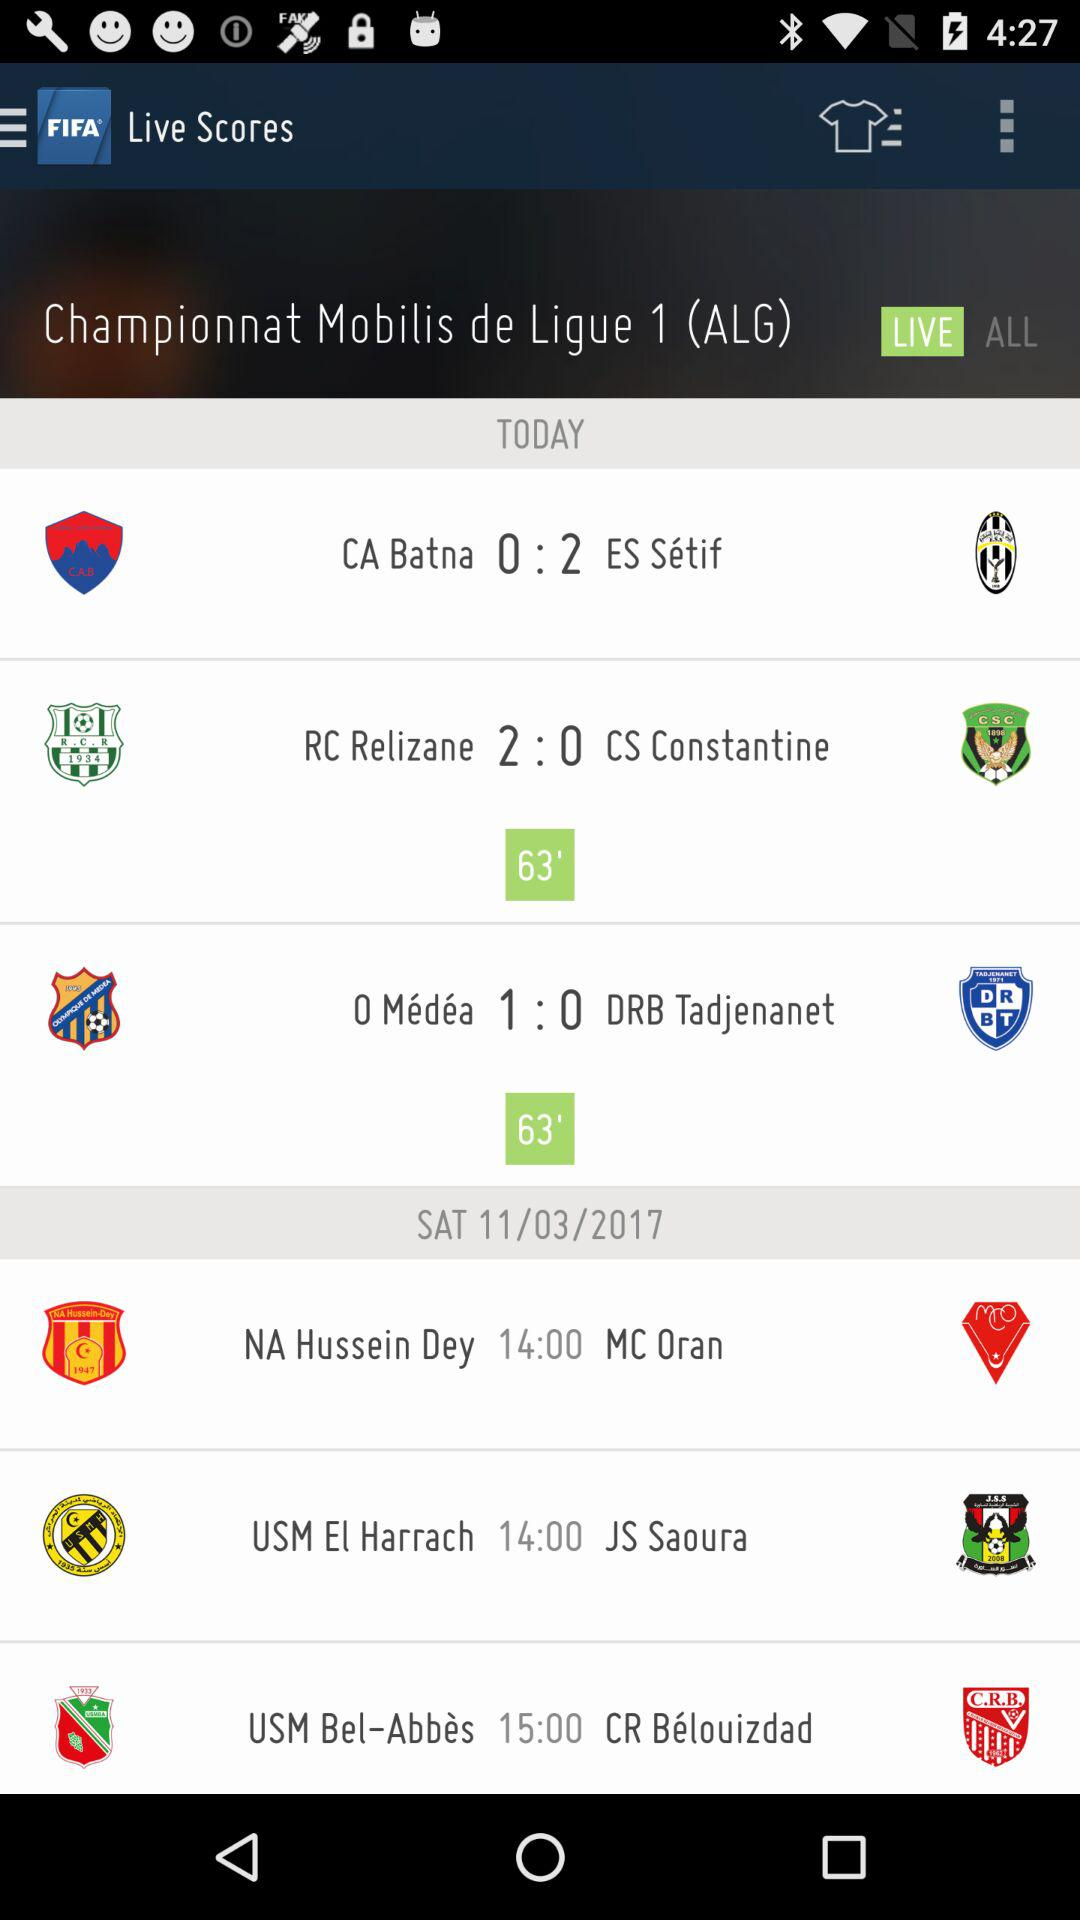Which teams are going to play today? The teams that are going to play are : "CA Batna", "ES Setif", "RC Relizane", "CS Constantine ", "O Medea", and "DRB Tadjenanet". 